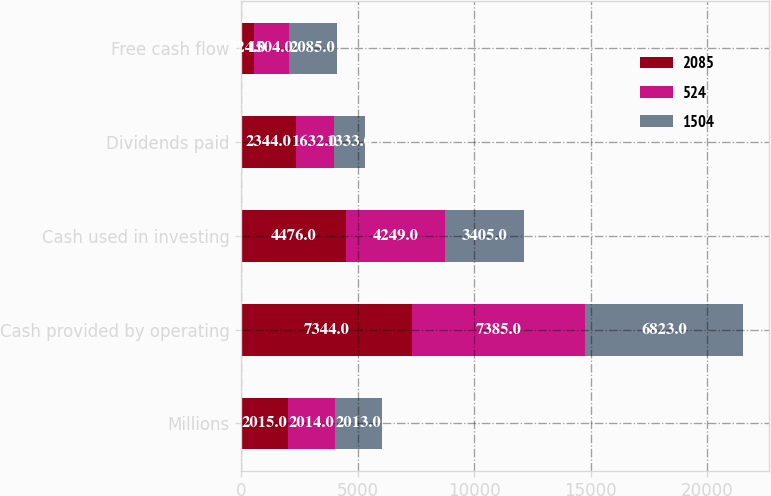<chart> <loc_0><loc_0><loc_500><loc_500><stacked_bar_chart><ecel><fcel>Millions<fcel>Cash provided by operating<fcel>Cash used in investing<fcel>Dividends paid<fcel>Free cash flow<nl><fcel>2085<fcel>2015<fcel>7344<fcel>4476<fcel>2344<fcel>524<nl><fcel>524<fcel>2014<fcel>7385<fcel>4249<fcel>1632<fcel>1504<nl><fcel>1504<fcel>2013<fcel>6823<fcel>3405<fcel>1333<fcel>2085<nl></chart> 